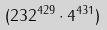<formula> <loc_0><loc_0><loc_500><loc_500>( 2 3 2 ^ { 4 2 9 } \cdot 4 ^ { 4 3 1 } )</formula> 